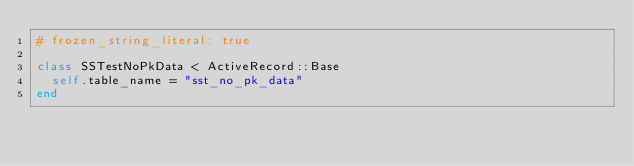Convert code to text. <code><loc_0><loc_0><loc_500><loc_500><_Ruby_># frozen_string_literal: true

class SSTestNoPkData < ActiveRecord::Base
  self.table_name = "sst_no_pk_data"
end
</code> 